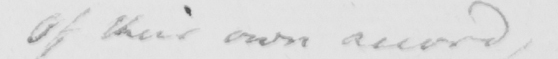What is written in this line of handwriting? of their own accord , 